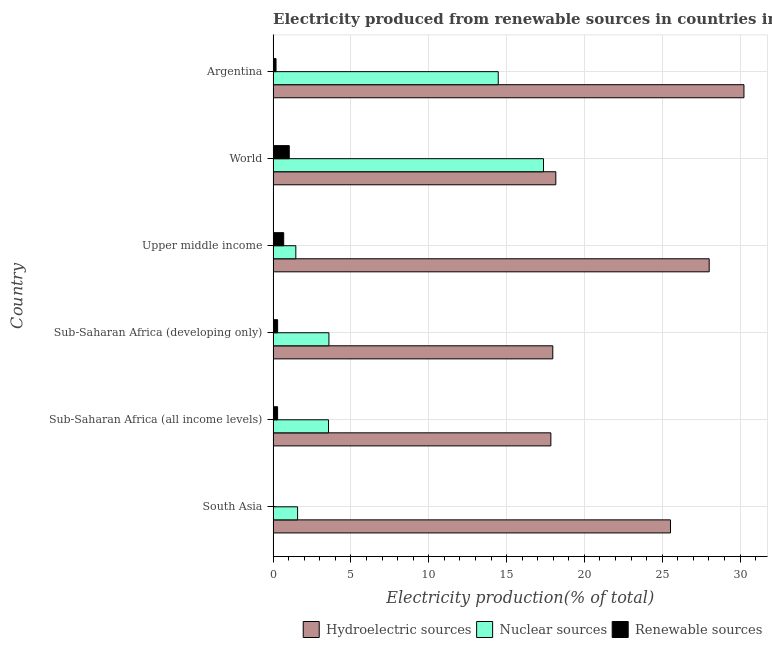How many different coloured bars are there?
Keep it short and to the point. 3. How many groups of bars are there?
Your answer should be compact. 6. Are the number of bars on each tick of the Y-axis equal?
Your response must be concise. Yes. What is the label of the 5th group of bars from the top?
Your answer should be compact. Sub-Saharan Africa (all income levels). What is the percentage of electricity produced by nuclear sources in World?
Make the answer very short. 17.37. Across all countries, what is the maximum percentage of electricity produced by nuclear sources?
Offer a very short reply. 17.37. Across all countries, what is the minimum percentage of electricity produced by renewable sources?
Make the answer very short. 0.01. In which country was the percentage of electricity produced by renewable sources minimum?
Offer a very short reply. South Asia. What is the total percentage of electricity produced by nuclear sources in the graph?
Your response must be concise. 42.01. What is the difference between the percentage of electricity produced by nuclear sources in South Asia and that in Sub-Saharan Africa (all income levels)?
Ensure brevity in your answer.  -1.99. What is the difference between the percentage of electricity produced by renewable sources in Argentina and the percentage of electricity produced by nuclear sources in Sub-Saharan Africa (all income levels)?
Provide a short and direct response. -3.37. What is the average percentage of electricity produced by hydroelectric sources per country?
Make the answer very short. 22.96. What is the difference between the percentage of electricity produced by nuclear sources and percentage of electricity produced by hydroelectric sources in Argentina?
Give a very brief answer. -15.79. What is the ratio of the percentage of electricity produced by hydroelectric sources in Sub-Saharan Africa (developing only) to that in Upper middle income?
Give a very brief answer. 0.64. Is the percentage of electricity produced by renewable sources in South Asia less than that in Sub-Saharan Africa (developing only)?
Offer a very short reply. Yes. What is the difference between the highest and the second highest percentage of electricity produced by renewable sources?
Your answer should be compact. 0.36. What is the difference between the highest and the lowest percentage of electricity produced by hydroelectric sources?
Give a very brief answer. 12.41. In how many countries, is the percentage of electricity produced by nuclear sources greater than the average percentage of electricity produced by nuclear sources taken over all countries?
Offer a very short reply. 2. Is the sum of the percentage of electricity produced by nuclear sources in Sub-Saharan Africa (all income levels) and Upper middle income greater than the maximum percentage of electricity produced by hydroelectric sources across all countries?
Ensure brevity in your answer.  No. What does the 3rd bar from the top in South Asia represents?
Ensure brevity in your answer.  Hydroelectric sources. What does the 2nd bar from the bottom in Argentina represents?
Your answer should be compact. Nuclear sources. Is it the case that in every country, the sum of the percentage of electricity produced by hydroelectric sources and percentage of electricity produced by nuclear sources is greater than the percentage of electricity produced by renewable sources?
Offer a very short reply. Yes. How many countries are there in the graph?
Your answer should be compact. 6. What is the difference between two consecutive major ticks on the X-axis?
Your response must be concise. 5. Are the values on the major ticks of X-axis written in scientific E-notation?
Provide a short and direct response. No. Does the graph contain any zero values?
Provide a succinct answer. No. Does the graph contain grids?
Your answer should be very brief. Yes. How many legend labels are there?
Your answer should be very brief. 3. What is the title of the graph?
Provide a succinct answer. Electricity produced from renewable sources in countries in 1991. Does "Communicable diseases" appear as one of the legend labels in the graph?
Your answer should be very brief. No. What is the label or title of the X-axis?
Offer a terse response. Electricity production(% of total). What is the label or title of the Y-axis?
Provide a succinct answer. Country. What is the Electricity production(% of total) in Hydroelectric sources in South Asia?
Offer a terse response. 25.53. What is the Electricity production(% of total) in Nuclear sources in South Asia?
Your response must be concise. 1.57. What is the Electricity production(% of total) of Renewable sources in South Asia?
Offer a very short reply. 0.01. What is the Electricity production(% of total) of Hydroelectric sources in Sub-Saharan Africa (all income levels)?
Your answer should be very brief. 17.84. What is the Electricity production(% of total) in Nuclear sources in Sub-Saharan Africa (all income levels)?
Your answer should be compact. 3.56. What is the Electricity production(% of total) of Renewable sources in Sub-Saharan Africa (all income levels)?
Offer a terse response. 0.29. What is the Electricity production(% of total) in Hydroelectric sources in Sub-Saharan Africa (developing only)?
Make the answer very short. 17.97. What is the Electricity production(% of total) in Nuclear sources in Sub-Saharan Africa (developing only)?
Offer a terse response. 3.59. What is the Electricity production(% of total) in Renewable sources in Sub-Saharan Africa (developing only)?
Your answer should be compact. 0.29. What is the Electricity production(% of total) of Hydroelectric sources in Upper middle income?
Provide a short and direct response. 28.02. What is the Electricity production(% of total) in Nuclear sources in Upper middle income?
Offer a very short reply. 1.46. What is the Electricity production(% of total) in Renewable sources in Upper middle income?
Your answer should be compact. 0.68. What is the Electricity production(% of total) of Hydroelectric sources in World?
Your response must be concise. 18.16. What is the Electricity production(% of total) in Nuclear sources in World?
Offer a very short reply. 17.37. What is the Electricity production(% of total) of Renewable sources in World?
Offer a terse response. 1.04. What is the Electricity production(% of total) in Hydroelectric sources in Argentina?
Keep it short and to the point. 30.25. What is the Electricity production(% of total) of Nuclear sources in Argentina?
Provide a short and direct response. 14.46. What is the Electricity production(% of total) of Renewable sources in Argentina?
Offer a terse response. 0.19. Across all countries, what is the maximum Electricity production(% of total) of Hydroelectric sources?
Provide a short and direct response. 30.25. Across all countries, what is the maximum Electricity production(% of total) of Nuclear sources?
Give a very brief answer. 17.37. Across all countries, what is the maximum Electricity production(% of total) in Renewable sources?
Your answer should be compact. 1.04. Across all countries, what is the minimum Electricity production(% of total) in Hydroelectric sources?
Keep it short and to the point. 17.84. Across all countries, what is the minimum Electricity production(% of total) of Nuclear sources?
Ensure brevity in your answer.  1.46. Across all countries, what is the minimum Electricity production(% of total) in Renewable sources?
Offer a terse response. 0.01. What is the total Electricity production(% of total) in Hydroelectric sources in the graph?
Provide a short and direct response. 137.77. What is the total Electricity production(% of total) in Nuclear sources in the graph?
Provide a short and direct response. 42.01. What is the total Electricity production(% of total) of Renewable sources in the graph?
Keep it short and to the point. 2.49. What is the difference between the Electricity production(% of total) in Hydroelectric sources in South Asia and that in Sub-Saharan Africa (all income levels)?
Offer a terse response. 7.69. What is the difference between the Electricity production(% of total) in Nuclear sources in South Asia and that in Sub-Saharan Africa (all income levels)?
Offer a terse response. -1.99. What is the difference between the Electricity production(% of total) in Renewable sources in South Asia and that in Sub-Saharan Africa (all income levels)?
Offer a terse response. -0.28. What is the difference between the Electricity production(% of total) of Hydroelectric sources in South Asia and that in Sub-Saharan Africa (developing only)?
Keep it short and to the point. 7.56. What is the difference between the Electricity production(% of total) in Nuclear sources in South Asia and that in Sub-Saharan Africa (developing only)?
Provide a succinct answer. -2.01. What is the difference between the Electricity production(% of total) in Renewable sources in South Asia and that in Sub-Saharan Africa (developing only)?
Your answer should be compact. -0.28. What is the difference between the Electricity production(% of total) of Hydroelectric sources in South Asia and that in Upper middle income?
Keep it short and to the point. -2.49. What is the difference between the Electricity production(% of total) in Nuclear sources in South Asia and that in Upper middle income?
Provide a short and direct response. 0.11. What is the difference between the Electricity production(% of total) in Renewable sources in South Asia and that in Upper middle income?
Provide a succinct answer. -0.67. What is the difference between the Electricity production(% of total) of Hydroelectric sources in South Asia and that in World?
Provide a succinct answer. 7.37. What is the difference between the Electricity production(% of total) of Nuclear sources in South Asia and that in World?
Provide a short and direct response. -15.8. What is the difference between the Electricity production(% of total) of Renewable sources in South Asia and that in World?
Keep it short and to the point. -1.03. What is the difference between the Electricity production(% of total) in Hydroelectric sources in South Asia and that in Argentina?
Keep it short and to the point. -4.72. What is the difference between the Electricity production(% of total) in Nuclear sources in South Asia and that in Argentina?
Give a very brief answer. -12.89. What is the difference between the Electricity production(% of total) of Renewable sources in South Asia and that in Argentina?
Offer a very short reply. -0.18. What is the difference between the Electricity production(% of total) of Hydroelectric sources in Sub-Saharan Africa (all income levels) and that in Sub-Saharan Africa (developing only)?
Offer a very short reply. -0.12. What is the difference between the Electricity production(% of total) in Nuclear sources in Sub-Saharan Africa (all income levels) and that in Sub-Saharan Africa (developing only)?
Your answer should be very brief. -0.02. What is the difference between the Electricity production(% of total) in Renewable sources in Sub-Saharan Africa (all income levels) and that in Sub-Saharan Africa (developing only)?
Make the answer very short. -0. What is the difference between the Electricity production(% of total) of Hydroelectric sources in Sub-Saharan Africa (all income levels) and that in Upper middle income?
Provide a succinct answer. -10.17. What is the difference between the Electricity production(% of total) in Nuclear sources in Sub-Saharan Africa (all income levels) and that in Upper middle income?
Keep it short and to the point. 2.1. What is the difference between the Electricity production(% of total) in Renewable sources in Sub-Saharan Africa (all income levels) and that in Upper middle income?
Ensure brevity in your answer.  -0.39. What is the difference between the Electricity production(% of total) in Hydroelectric sources in Sub-Saharan Africa (all income levels) and that in World?
Ensure brevity in your answer.  -0.32. What is the difference between the Electricity production(% of total) of Nuclear sources in Sub-Saharan Africa (all income levels) and that in World?
Offer a very short reply. -13.81. What is the difference between the Electricity production(% of total) in Renewable sources in Sub-Saharan Africa (all income levels) and that in World?
Your answer should be very brief. -0.75. What is the difference between the Electricity production(% of total) of Hydroelectric sources in Sub-Saharan Africa (all income levels) and that in Argentina?
Provide a short and direct response. -12.41. What is the difference between the Electricity production(% of total) in Nuclear sources in Sub-Saharan Africa (all income levels) and that in Argentina?
Ensure brevity in your answer.  -10.9. What is the difference between the Electricity production(% of total) of Renewable sources in Sub-Saharan Africa (all income levels) and that in Argentina?
Offer a terse response. 0.1. What is the difference between the Electricity production(% of total) in Hydroelectric sources in Sub-Saharan Africa (developing only) and that in Upper middle income?
Make the answer very short. -10.05. What is the difference between the Electricity production(% of total) in Nuclear sources in Sub-Saharan Africa (developing only) and that in Upper middle income?
Your response must be concise. 2.13. What is the difference between the Electricity production(% of total) of Renewable sources in Sub-Saharan Africa (developing only) and that in Upper middle income?
Your answer should be very brief. -0.39. What is the difference between the Electricity production(% of total) in Hydroelectric sources in Sub-Saharan Africa (developing only) and that in World?
Keep it short and to the point. -0.19. What is the difference between the Electricity production(% of total) of Nuclear sources in Sub-Saharan Africa (developing only) and that in World?
Provide a succinct answer. -13.79. What is the difference between the Electricity production(% of total) of Renewable sources in Sub-Saharan Africa (developing only) and that in World?
Your response must be concise. -0.75. What is the difference between the Electricity production(% of total) of Hydroelectric sources in Sub-Saharan Africa (developing only) and that in Argentina?
Make the answer very short. -12.28. What is the difference between the Electricity production(% of total) in Nuclear sources in Sub-Saharan Africa (developing only) and that in Argentina?
Offer a very short reply. -10.88. What is the difference between the Electricity production(% of total) in Renewable sources in Sub-Saharan Africa (developing only) and that in Argentina?
Provide a short and direct response. 0.1. What is the difference between the Electricity production(% of total) of Hydroelectric sources in Upper middle income and that in World?
Make the answer very short. 9.85. What is the difference between the Electricity production(% of total) in Nuclear sources in Upper middle income and that in World?
Your answer should be compact. -15.91. What is the difference between the Electricity production(% of total) in Renewable sources in Upper middle income and that in World?
Your answer should be very brief. -0.36. What is the difference between the Electricity production(% of total) in Hydroelectric sources in Upper middle income and that in Argentina?
Your answer should be very brief. -2.23. What is the difference between the Electricity production(% of total) of Nuclear sources in Upper middle income and that in Argentina?
Keep it short and to the point. -13. What is the difference between the Electricity production(% of total) of Renewable sources in Upper middle income and that in Argentina?
Provide a short and direct response. 0.49. What is the difference between the Electricity production(% of total) of Hydroelectric sources in World and that in Argentina?
Offer a very short reply. -12.09. What is the difference between the Electricity production(% of total) of Nuclear sources in World and that in Argentina?
Your answer should be very brief. 2.91. What is the difference between the Electricity production(% of total) in Renewable sources in World and that in Argentina?
Offer a terse response. 0.85. What is the difference between the Electricity production(% of total) in Hydroelectric sources in South Asia and the Electricity production(% of total) in Nuclear sources in Sub-Saharan Africa (all income levels)?
Offer a terse response. 21.97. What is the difference between the Electricity production(% of total) in Hydroelectric sources in South Asia and the Electricity production(% of total) in Renewable sources in Sub-Saharan Africa (all income levels)?
Your answer should be compact. 25.24. What is the difference between the Electricity production(% of total) of Nuclear sources in South Asia and the Electricity production(% of total) of Renewable sources in Sub-Saharan Africa (all income levels)?
Your response must be concise. 1.29. What is the difference between the Electricity production(% of total) in Hydroelectric sources in South Asia and the Electricity production(% of total) in Nuclear sources in Sub-Saharan Africa (developing only)?
Provide a succinct answer. 21.95. What is the difference between the Electricity production(% of total) of Hydroelectric sources in South Asia and the Electricity production(% of total) of Renewable sources in Sub-Saharan Africa (developing only)?
Your answer should be compact. 25.24. What is the difference between the Electricity production(% of total) of Nuclear sources in South Asia and the Electricity production(% of total) of Renewable sources in Sub-Saharan Africa (developing only)?
Provide a short and direct response. 1.28. What is the difference between the Electricity production(% of total) in Hydroelectric sources in South Asia and the Electricity production(% of total) in Nuclear sources in Upper middle income?
Ensure brevity in your answer.  24.07. What is the difference between the Electricity production(% of total) in Hydroelectric sources in South Asia and the Electricity production(% of total) in Renewable sources in Upper middle income?
Make the answer very short. 24.85. What is the difference between the Electricity production(% of total) of Nuclear sources in South Asia and the Electricity production(% of total) of Renewable sources in Upper middle income?
Your response must be concise. 0.89. What is the difference between the Electricity production(% of total) of Hydroelectric sources in South Asia and the Electricity production(% of total) of Nuclear sources in World?
Provide a short and direct response. 8.16. What is the difference between the Electricity production(% of total) in Hydroelectric sources in South Asia and the Electricity production(% of total) in Renewable sources in World?
Your answer should be very brief. 24.49. What is the difference between the Electricity production(% of total) in Nuclear sources in South Asia and the Electricity production(% of total) in Renewable sources in World?
Your response must be concise. 0.54. What is the difference between the Electricity production(% of total) in Hydroelectric sources in South Asia and the Electricity production(% of total) in Nuclear sources in Argentina?
Your answer should be very brief. 11.07. What is the difference between the Electricity production(% of total) in Hydroelectric sources in South Asia and the Electricity production(% of total) in Renewable sources in Argentina?
Keep it short and to the point. 25.34. What is the difference between the Electricity production(% of total) in Nuclear sources in South Asia and the Electricity production(% of total) in Renewable sources in Argentina?
Your response must be concise. 1.39. What is the difference between the Electricity production(% of total) of Hydroelectric sources in Sub-Saharan Africa (all income levels) and the Electricity production(% of total) of Nuclear sources in Sub-Saharan Africa (developing only)?
Make the answer very short. 14.26. What is the difference between the Electricity production(% of total) of Hydroelectric sources in Sub-Saharan Africa (all income levels) and the Electricity production(% of total) of Renewable sources in Sub-Saharan Africa (developing only)?
Your answer should be compact. 17.55. What is the difference between the Electricity production(% of total) in Nuclear sources in Sub-Saharan Africa (all income levels) and the Electricity production(% of total) in Renewable sources in Sub-Saharan Africa (developing only)?
Your answer should be compact. 3.27. What is the difference between the Electricity production(% of total) in Hydroelectric sources in Sub-Saharan Africa (all income levels) and the Electricity production(% of total) in Nuclear sources in Upper middle income?
Your answer should be compact. 16.38. What is the difference between the Electricity production(% of total) in Hydroelectric sources in Sub-Saharan Africa (all income levels) and the Electricity production(% of total) in Renewable sources in Upper middle income?
Give a very brief answer. 17.16. What is the difference between the Electricity production(% of total) of Nuclear sources in Sub-Saharan Africa (all income levels) and the Electricity production(% of total) of Renewable sources in Upper middle income?
Make the answer very short. 2.88. What is the difference between the Electricity production(% of total) of Hydroelectric sources in Sub-Saharan Africa (all income levels) and the Electricity production(% of total) of Nuclear sources in World?
Offer a terse response. 0.47. What is the difference between the Electricity production(% of total) of Hydroelectric sources in Sub-Saharan Africa (all income levels) and the Electricity production(% of total) of Renewable sources in World?
Keep it short and to the point. 16.81. What is the difference between the Electricity production(% of total) of Nuclear sources in Sub-Saharan Africa (all income levels) and the Electricity production(% of total) of Renewable sources in World?
Make the answer very short. 2.52. What is the difference between the Electricity production(% of total) in Hydroelectric sources in Sub-Saharan Africa (all income levels) and the Electricity production(% of total) in Nuclear sources in Argentina?
Offer a very short reply. 3.38. What is the difference between the Electricity production(% of total) of Hydroelectric sources in Sub-Saharan Africa (all income levels) and the Electricity production(% of total) of Renewable sources in Argentina?
Make the answer very short. 17.66. What is the difference between the Electricity production(% of total) in Nuclear sources in Sub-Saharan Africa (all income levels) and the Electricity production(% of total) in Renewable sources in Argentina?
Provide a short and direct response. 3.37. What is the difference between the Electricity production(% of total) of Hydroelectric sources in Sub-Saharan Africa (developing only) and the Electricity production(% of total) of Nuclear sources in Upper middle income?
Keep it short and to the point. 16.51. What is the difference between the Electricity production(% of total) of Hydroelectric sources in Sub-Saharan Africa (developing only) and the Electricity production(% of total) of Renewable sources in Upper middle income?
Your answer should be very brief. 17.29. What is the difference between the Electricity production(% of total) in Nuclear sources in Sub-Saharan Africa (developing only) and the Electricity production(% of total) in Renewable sources in Upper middle income?
Your answer should be very brief. 2.91. What is the difference between the Electricity production(% of total) in Hydroelectric sources in Sub-Saharan Africa (developing only) and the Electricity production(% of total) in Nuclear sources in World?
Ensure brevity in your answer.  0.6. What is the difference between the Electricity production(% of total) in Hydroelectric sources in Sub-Saharan Africa (developing only) and the Electricity production(% of total) in Renewable sources in World?
Give a very brief answer. 16.93. What is the difference between the Electricity production(% of total) of Nuclear sources in Sub-Saharan Africa (developing only) and the Electricity production(% of total) of Renewable sources in World?
Provide a succinct answer. 2.55. What is the difference between the Electricity production(% of total) of Hydroelectric sources in Sub-Saharan Africa (developing only) and the Electricity production(% of total) of Nuclear sources in Argentina?
Ensure brevity in your answer.  3.5. What is the difference between the Electricity production(% of total) in Hydroelectric sources in Sub-Saharan Africa (developing only) and the Electricity production(% of total) in Renewable sources in Argentina?
Your response must be concise. 17.78. What is the difference between the Electricity production(% of total) in Nuclear sources in Sub-Saharan Africa (developing only) and the Electricity production(% of total) in Renewable sources in Argentina?
Give a very brief answer. 3.4. What is the difference between the Electricity production(% of total) of Hydroelectric sources in Upper middle income and the Electricity production(% of total) of Nuclear sources in World?
Your response must be concise. 10.65. What is the difference between the Electricity production(% of total) in Hydroelectric sources in Upper middle income and the Electricity production(% of total) in Renewable sources in World?
Ensure brevity in your answer.  26.98. What is the difference between the Electricity production(% of total) in Nuclear sources in Upper middle income and the Electricity production(% of total) in Renewable sources in World?
Keep it short and to the point. 0.42. What is the difference between the Electricity production(% of total) in Hydroelectric sources in Upper middle income and the Electricity production(% of total) in Nuclear sources in Argentina?
Your response must be concise. 13.55. What is the difference between the Electricity production(% of total) in Hydroelectric sources in Upper middle income and the Electricity production(% of total) in Renewable sources in Argentina?
Keep it short and to the point. 27.83. What is the difference between the Electricity production(% of total) of Nuclear sources in Upper middle income and the Electricity production(% of total) of Renewable sources in Argentina?
Your answer should be very brief. 1.27. What is the difference between the Electricity production(% of total) in Hydroelectric sources in World and the Electricity production(% of total) in Nuclear sources in Argentina?
Give a very brief answer. 3.7. What is the difference between the Electricity production(% of total) in Hydroelectric sources in World and the Electricity production(% of total) in Renewable sources in Argentina?
Your answer should be very brief. 17.98. What is the difference between the Electricity production(% of total) of Nuclear sources in World and the Electricity production(% of total) of Renewable sources in Argentina?
Keep it short and to the point. 17.18. What is the average Electricity production(% of total) of Hydroelectric sources per country?
Provide a short and direct response. 22.96. What is the average Electricity production(% of total) in Nuclear sources per country?
Give a very brief answer. 7. What is the average Electricity production(% of total) of Renewable sources per country?
Your answer should be very brief. 0.41. What is the difference between the Electricity production(% of total) of Hydroelectric sources and Electricity production(% of total) of Nuclear sources in South Asia?
Your response must be concise. 23.96. What is the difference between the Electricity production(% of total) in Hydroelectric sources and Electricity production(% of total) in Renewable sources in South Asia?
Provide a short and direct response. 25.52. What is the difference between the Electricity production(% of total) of Nuclear sources and Electricity production(% of total) of Renewable sources in South Asia?
Keep it short and to the point. 1.56. What is the difference between the Electricity production(% of total) of Hydroelectric sources and Electricity production(% of total) of Nuclear sources in Sub-Saharan Africa (all income levels)?
Give a very brief answer. 14.28. What is the difference between the Electricity production(% of total) in Hydroelectric sources and Electricity production(% of total) in Renewable sources in Sub-Saharan Africa (all income levels)?
Your answer should be very brief. 17.56. What is the difference between the Electricity production(% of total) of Nuclear sources and Electricity production(% of total) of Renewable sources in Sub-Saharan Africa (all income levels)?
Keep it short and to the point. 3.27. What is the difference between the Electricity production(% of total) in Hydroelectric sources and Electricity production(% of total) in Nuclear sources in Sub-Saharan Africa (developing only)?
Your answer should be compact. 14.38. What is the difference between the Electricity production(% of total) in Hydroelectric sources and Electricity production(% of total) in Renewable sources in Sub-Saharan Africa (developing only)?
Ensure brevity in your answer.  17.68. What is the difference between the Electricity production(% of total) of Nuclear sources and Electricity production(% of total) of Renewable sources in Sub-Saharan Africa (developing only)?
Your answer should be very brief. 3.3. What is the difference between the Electricity production(% of total) of Hydroelectric sources and Electricity production(% of total) of Nuclear sources in Upper middle income?
Offer a terse response. 26.56. What is the difference between the Electricity production(% of total) of Hydroelectric sources and Electricity production(% of total) of Renewable sources in Upper middle income?
Your response must be concise. 27.34. What is the difference between the Electricity production(% of total) of Nuclear sources and Electricity production(% of total) of Renewable sources in Upper middle income?
Make the answer very short. 0.78. What is the difference between the Electricity production(% of total) of Hydroelectric sources and Electricity production(% of total) of Nuclear sources in World?
Offer a very short reply. 0.79. What is the difference between the Electricity production(% of total) in Hydroelectric sources and Electricity production(% of total) in Renewable sources in World?
Make the answer very short. 17.13. What is the difference between the Electricity production(% of total) of Nuclear sources and Electricity production(% of total) of Renewable sources in World?
Your answer should be compact. 16.33. What is the difference between the Electricity production(% of total) of Hydroelectric sources and Electricity production(% of total) of Nuclear sources in Argentina?
Make the answer very short. 15.79. What is the difference between the Electricity production(% of total) in Hydroelectric sources and Electricity production(% of total) in Renewable sources in Argentina?
Offer a terse response. 30.06. What is the difference between the Electricity production(% of total) in Nuclear sources and Electricity production(% of total) in Renewable sources in Argentina?
Give a very brief answer. 14.28. What is the ratio of the Electricity production(% of total) of Hydroelectric sources in South Asia to that in Sub-Saharan Africa (all income levels)?
Provide a short and direct response. 1.43. What is the ratio of the Electricity production(% of total) of Nuclear sources in South Asia to that in Sub-Saharan Africa (all income levels)?
Offer a terse response. 0.44. What is the ratio of the Electricity production(% of total) of Renewable sources in South Asia to that in Sub-Saharan Africa (all income levels)?
Your answer should be compact. 0.04. What is the ratio of the Electricity production(% of total) in Hydroelectric sources in South Asia to that in Sub-Saharan Africa (developing only)?
Provide a short and direct response. 1.42. What is the ratio of the Electricity production(% of total) of Nuclear sources in South Asia to that in Sub-Saharan Africa (developing only)?
Ensure brevity in your answer.  0.44. What is the ratio of the Electricity production(% of total) in Renewable sources in South Asia to that in Sub-Saharan Africa (developing only)?
Offer a terse response. 0.04. What is the ratio of the Electricity production(% of total) of Hydroelectric sources in South Asia to that in Upper middle income?
Keep it short and to the point. 0.91. What is the ratio of the Electricity production(% of total) of Nuclear sources in South Asia to that in Upper middle income?
Give a very brief answer. 1.08. What is the ratio of the Electricity production(% of total) in Renewable sources in South Asia to that in Upper middle income?
Your answer should be very brief. 0.02. What is the ratio of the Electricity production(% of total) of Hydroelectric sources in South Asia to that in World?
Make the answer very short. 1.41. What is the ratio of the Electricity production(% of total) in Nuclear sources in South Asia to that in World?
Keep it short and to the point. 0.09. What is the ratio of the Electricity production(% of total) in Renewable sources in South Asia to that in World?
Provide a short and direct response. 0.01. What is the ratio of the Electricity production(% of total) of Hydroelectric sources in South Asia to that in Argentina?
Your response must be concise. 0.84. What is the ratio of the Electricity production(% of total) of Nuclear sources in South Asia to that in Argentina?
Ensure brevity in your answer.  0.11. What is the ratio of the Electricity production(% of total) in Renewable sources in South Asia to that in Argentina?
Your answer should be compact. 0.06. What is the ratio of the Electricity production(% of total) in Renewable sources in Sub-Saharan Africa (all income levels) to that in Sub-Saharan Africa (developing only)?
Your answer should be compact. 0.99. What is the ratio of the Electricity production(% of total) of Hydroelectric sources in Sub-Saharan Africa (all income levels) to that in Upper middle income?
Offer a terse response. 0.64. What is the ratio of the Electricity production(% of total) of Nuclear sources in Sub-Saharan Africa (all income levels) to that in Upper middle income?
Offer a terse response. 2.44. What is the ratio of the Electricity production(% of total) in Renewable sources in Sub-Saharan Africa (all income levels) to that in Upper middle income?
Your answer should be compact. 0.42. What is the ratio of the Electricity production(% of total) of Hydroelectric sources in Sub-Saharan Africa (all income levels) to that in World?
Give a very brief answer. 0.98. What is the ratio of the Electricity production(% of total) in Nuclear sources in Sub-Saharan Africa (all income levels) to that in World?
Ensure brevity in your answer.  0.2. What is the ratio of the Electricity production(% of total) in Renewable sources in Sub-Saharan Africa (all income levels) to that in World?
Offer a very short reply. 0.28. What is the ratio of the Electricity production(% of total) in Hydroelectric sources in Sub-Saharan Africa (all income levels) to that in Argentina?
Ensure brevity in your answer.  0.59. What is the ratio of the Electricity production(% of total) in Nuclear sources in Sub-Saharan Africa (all income levels) to that in Argentina?
Your answer should be very brief. 0.25. What is the ratio of the Electricity production(% of total) in Renewable sources in Sub-Saharan Africa (all income levels) to that in Argentina?
Your answer should be compact. 1.54. What is the ratio of the Electricity production(% of total) of Hydroelectric sources in Sub-Saharan Africa (developing only) to that in Upper middle income?
Your answer should be compact. 0.64. What is the ratio of the Electricity production(% of total) in Nuclear sources in Sub-Saharan Africa (developing only) to that in Upper middle income?
Keep it short and to the point. 2.46. What is the ratio of the Electricity production(% of total) in Renewable sources in Sub-Saharan Africa (developing only) to that in Upper middle income?
Make the answer very short. 0.43. What is the ratio of the Electricity production(% of total) in Hydroelectric sources in Sub-Saharan Africa (developing only) to that in World?
Your answer should be very brief. 0.99. What is the ratio of the Electricity production(% of total) of Nuclear sources in Sub-Saharan Africa (developing only) to that in World?
Provide a succinct answer. 0.21. What is the ratio of the Electricity production(% of total) of Renewable sources in Sub-Saharan Africa (developing only) to that in World?
Provide a succinct answer. 0.28. What is the ratio of the Electricity production(% of total) in Hydroelectric sources in Sub-Saharan Africa (developing only) to that in Argentina?
Ensure brevity in your answer.  0.59. What is the ratio of the Electricity production(% of total) of Nuclear sources in Sub-Saharan Africa (developing only) to that in Argentina?
Provide a succinct answer. 0.25. What is the ratio of the Electricity production(% of total) of Renewable sources in Sub-Saharan Africa (developing only) to that in Argentina?
Offer a very short reply. 1.55. What is the ratio of the Electricity production(% of total) of Hydroelectric sources in Upper middle income to that in World?
Your response must be concise. 1.54. What is the ratio of the Electricity production(% of total) in Nuclear sources in Upper middle income to that in World?
Offer a very short reply. 0.08. What is the ratio of the Electricity production(% of total) in Renewable sources in Upper middle income to that in World?
Provide a short and direct response. 0.66. What is the ratio of the Electricity production(% of total) in Hydroelectric sources in Upper middle income to that in Argentina?
Make the answer very short. 0.93. What is the ratio of the Electricity production(% of total) of Nuclear sources in Upper middle income to that in Argentina?
Offer a terse response. 0.1. What is the ratio of the Electricity production(% of total) of Renewable sources in Upper middle income to that in Argentina?
Provide a succinct answer. 3.65. What is the ratio of the Electricity production(% of total) of Hydroelectric sources in World to that in Argentina?
Your answer should be very brief. 0.6. What is the ratio of the Electricity production(% of total) of Nuclear sources in World to that in Argentina?
Ensure brevity in your answer.  1.2. What is the ratio of the Electricity production(% of total) of Renewable sources in World to that in Argentina?
Provide a short and direct response. 5.56. What is the difference between the highest and the second highest Electricity production(% of total) of Hydroelectric sources?
Your answer should be compact. 2.23. What is the difference between the highest and the second highest Electricity production(% of total) in Nuclear sources?
Ensure brevity in your answer.  2.91. What is the difference between the highest and the second highest Electricity production(% of total) of Renewable sources?
Your response must be concise. 0.36. What is the difference between the highest and the lowest Electricity production(% of total) of Hydroelectric sources?
Offer a terse response. 12.41. What is the difference between the highest and the lowest Electricity production(% of total) in Nuclear sources?
Give a very brief answer. 15.91. What is the difference between the highest and the lowest Electricity production(% of total) of Renewable sources?
Ensure brevity in your answer.  1.03. 